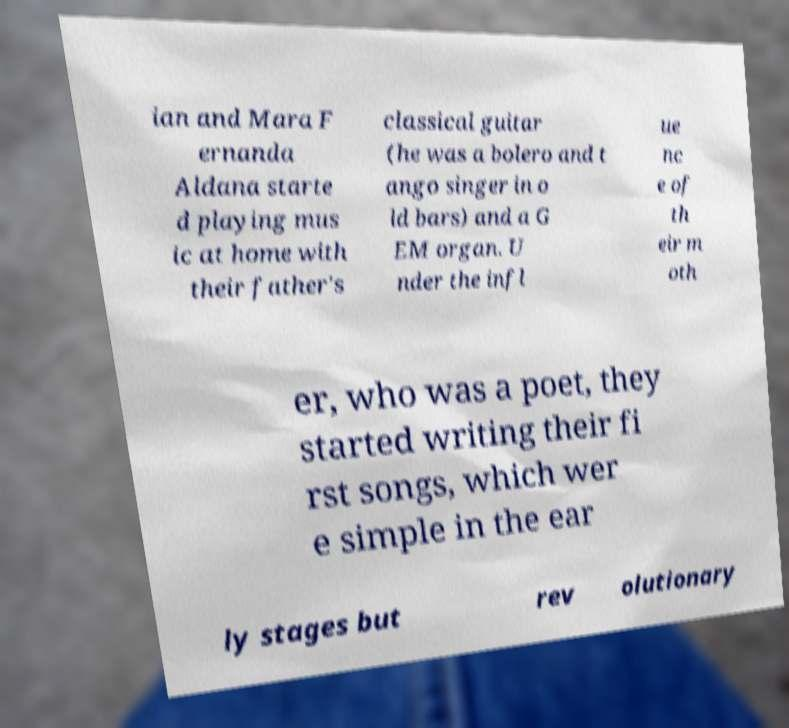Can you read and provide the text displayed in the image?This photo seems to have some interesting text. Can you extract and type it out for me? ian and Mara F ernanda Aldana starte d playing mus ic at home with their father's classical guitar (he was a bolero and t ango singer in o ld bars) and a G EM organ. U nder the infl ue nc e of th eir m oth er, who was a poet, they started writing their fi rst songs, which wer e simple in the ear ly stages but rev olutionary 